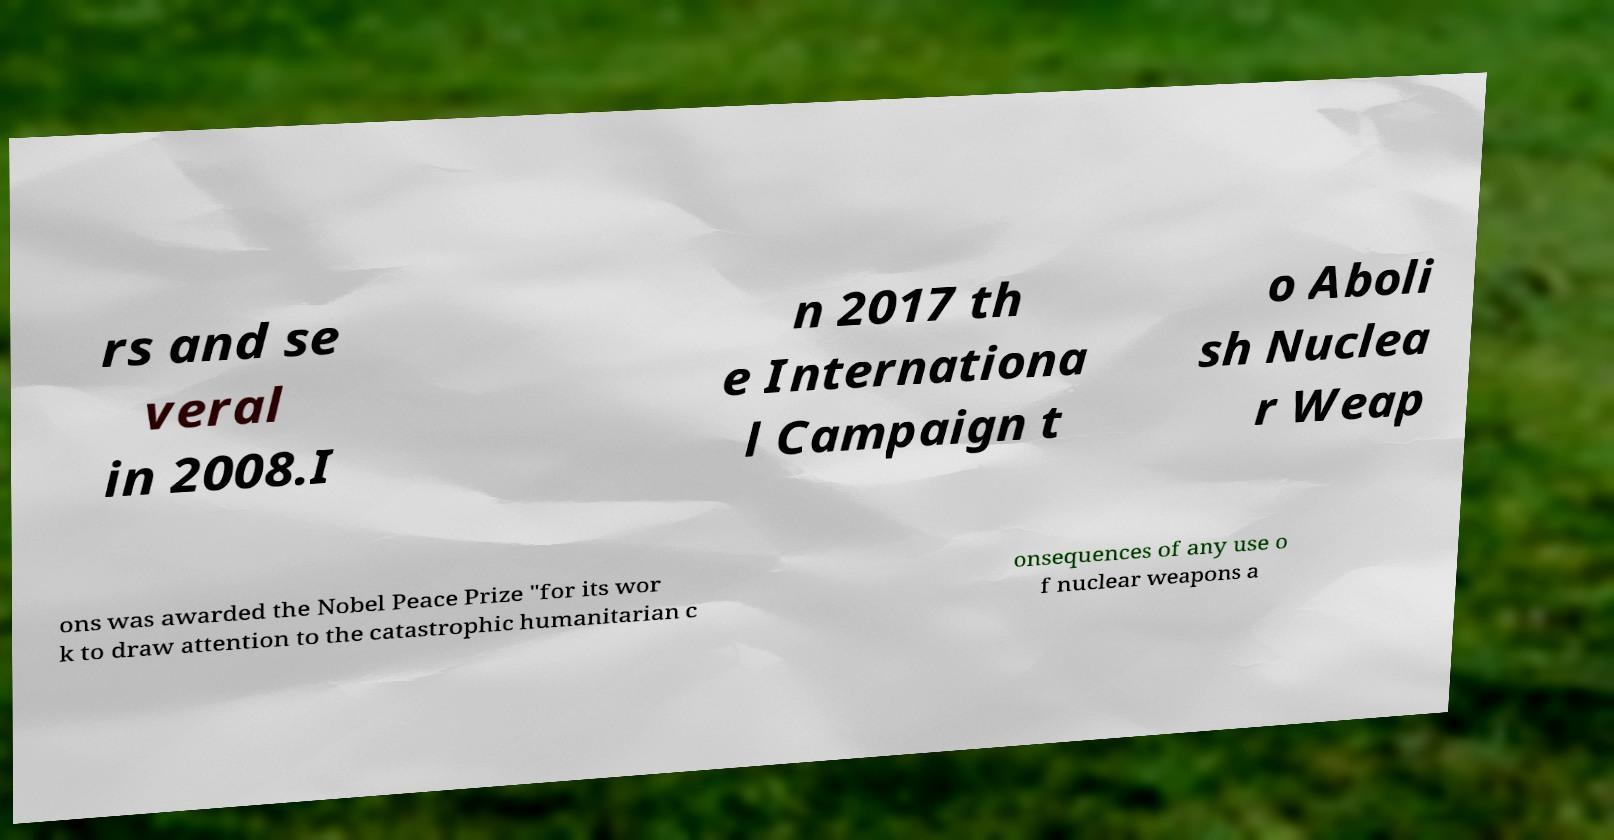Please read and relay the text visible in this image. What does it say? rs and se veral in 2008.I n 2017 th e Internationa l Campaign t o Aboli sh Nuclea r Weap ons was awarded the Nobel Peace Prize "for its wor k to draw attention to the catastrophic humanitarian c onsequences of any use o f nuclear weapons a 